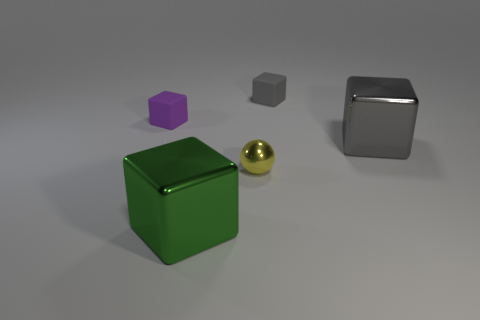Subtract all purple cubes. How many cubes are left? 3 Subtract all green blocks. How many blocks are left? 3 Subtract all spheres. How many objects are left? 4 Subtract 1 spheres. How many spheres are left? 0 Subtract 0 brown cylinders. How many objects are left? 5 Subtract all purple balls. Subtract all green blocks. How many balls are left? 1 Subtract all yellow cubes. How many brown balls are left? 0 Subtract all matte cubes. Subtract all large gray metallic things. How many objects are left? 2 Add 2 tiny purple things. How many tiny purple things are left? 3 Add 2 large green rubber blocks. How many large green rubber blocks exist? 2 